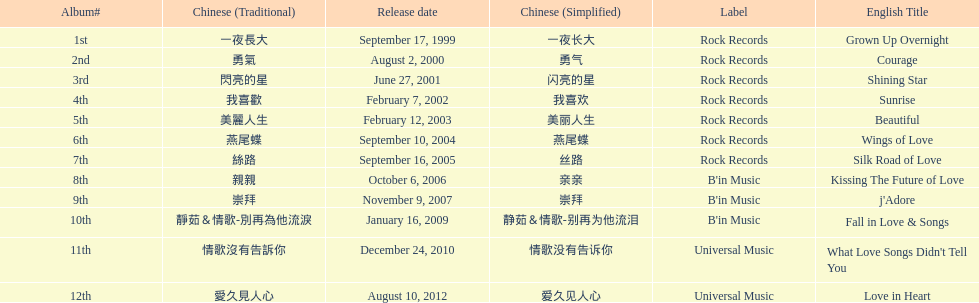Was the album beautiful released before the album love in heart? Yes. 